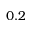<formula> <loc_0><loc_0><loc_500><loc_500>0 . 2</formula> 